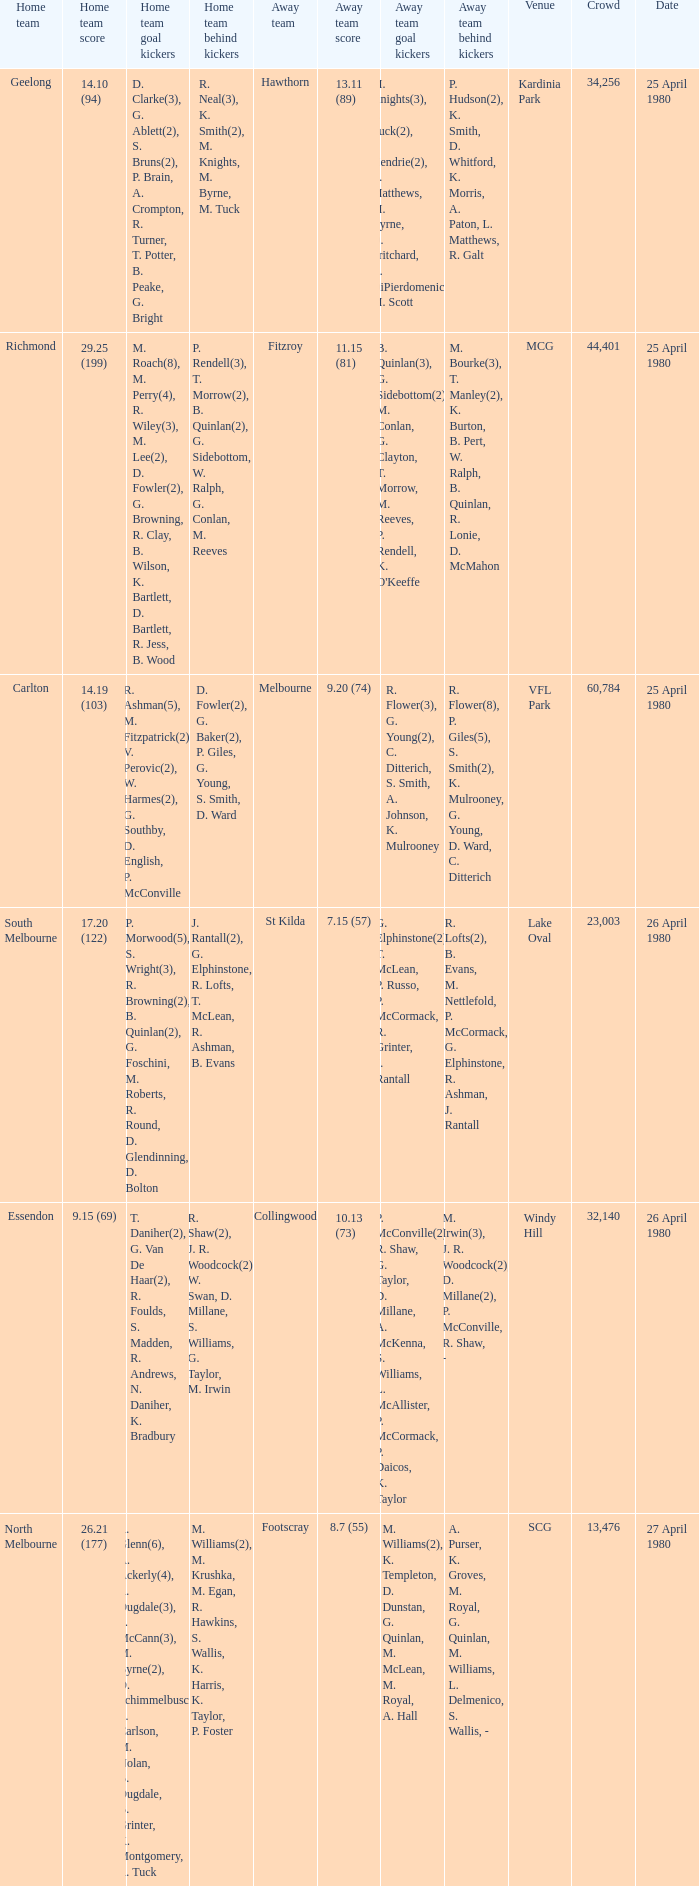What was the lowest crowd size at MCG? 44401.0. 